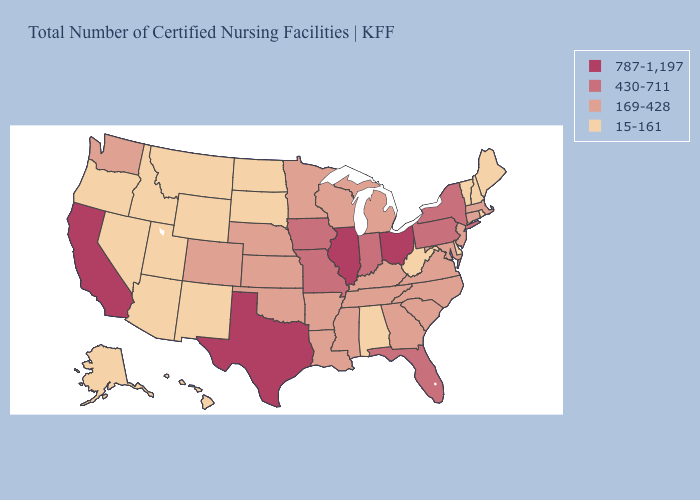Which states have the lowest value in the USA?
Write a very short answer. Alabama, Alaska, Arizona, Delaware, Hawaii, Idaho, Maine, Montana, Nevada, New Hampshire, New Mexico, North Dakota, Oregon, Rhode Island, South Dakota, Utah, Vermont, West Virginia, Wyoming. What is the highest value in the MidWest ?
Answer briefly. 787-1,197. Name the states that have a value in the range 787-1,197?
Write a very short answer. California, Illinois, Ohio, Texas. What is the value of Indiana?
Short answer required. 430-711. What is the highest value in the USA?
Concise answer only. 787-1,197. Does the map have missing data?
Write a very short answer. No. Does Pennsylvania have the lowest value in the Northeast?
Quick response, please. No. Does New York have a lower value than Illinois?
Answer briefly. Yes. Name the states that have a value in the range 169-428?
Keep it brief. Arkansas, Colorado, Connecticut, Georgia, Kansas, Kentucky, Louisiana, Maryland, Massachusetts, Michigan, Minnesota, Mississippi, Nebraska, New Jersey, North Carolina, Oklahoma, South Carolina, Tennessee, Virginia, Washington, Wisconsin. Name the states that have a value in the range 430-711?
Short answer required. Florida, Indiana, Iowa, Missouri, New York, Pennsylvania. What is the highest value in states that border Delaware?
Give a very brief answer. 430-711. Among the states that border Wyoming , which have the highest value?
Write a very short answer. Colorado, Nebraska. Which states have the lowest value in the South?
Write a very short answer. Alabama, Delaware, West Virginia. Does New York have the same value as North Carolina?
Answer briefly. No. Is the legend a continuous bar?
Write a very short answer. No. 